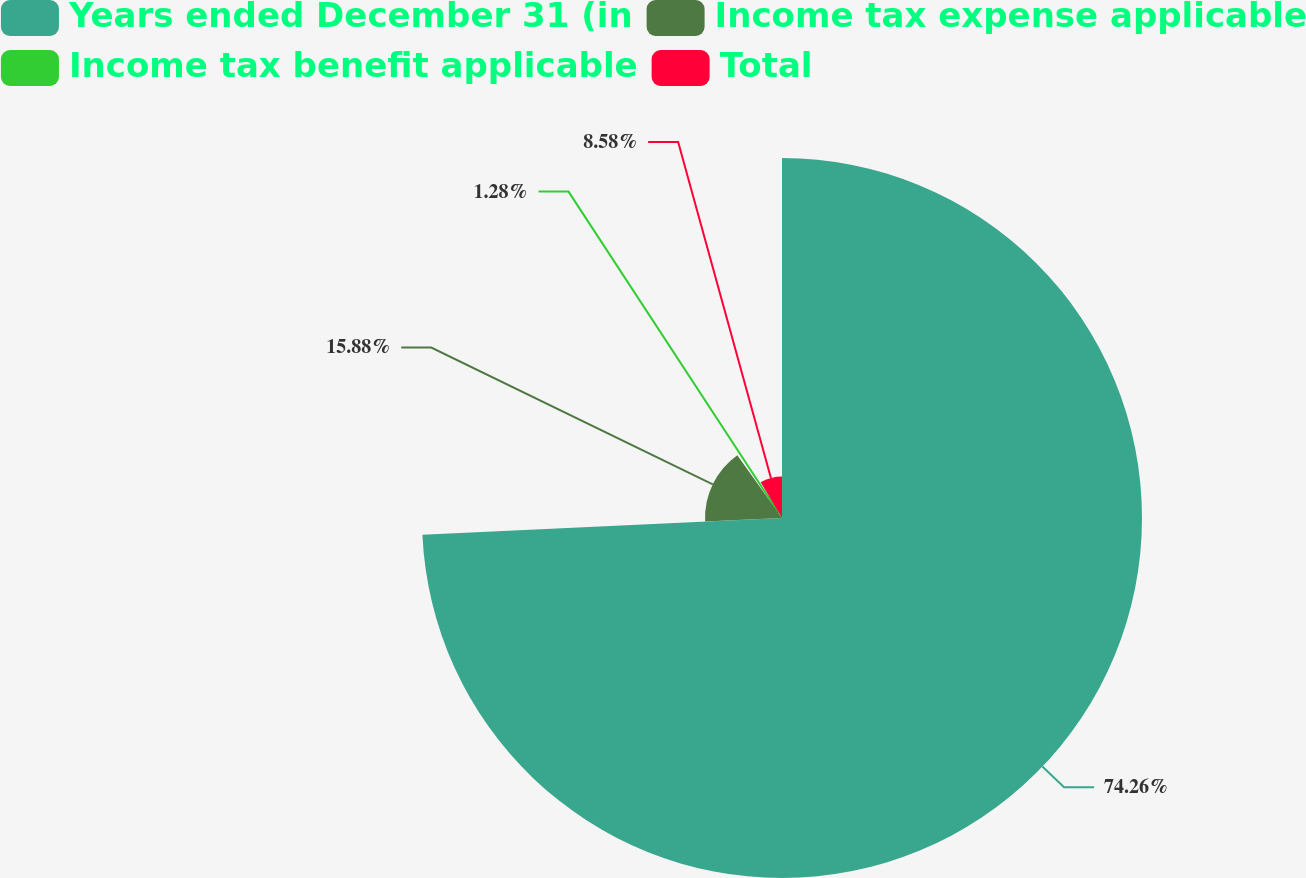<chart> <loc_0><loc_0><loc_500><loc_500><pie_chart><fcel>Years ended December 31 (in<fcel>Income tax expense applicable<fcel>Income tax benefit applicable<fcel>Total<nl><fcel>74.27%<fcel>15.88%<fcel>1.28%<fcel>8.58%<nl></chart> 